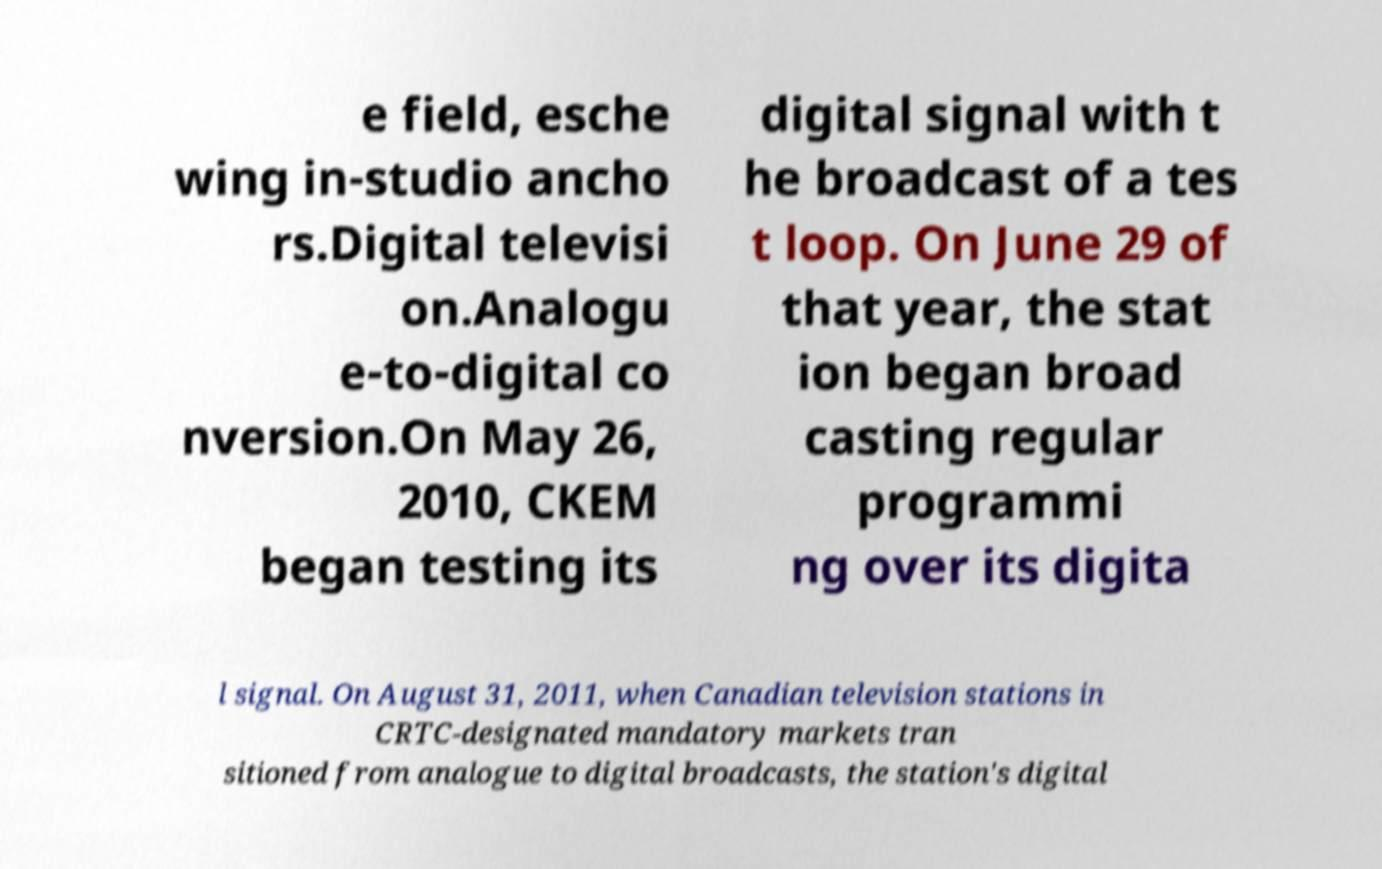Please read and relay the text visible in this image. What does it say? e field, esche wing in-studio ancho rs.Digital televisi on.Analogu e-to-digital co nversion.On May 26, 2010, CKEM began testing its digital signal with t he broadcast of a tes t loop. On June 29 of that year, the stat ion began broad casting regular programmi ng over its digita l signal. On August 31, 2011, when Canadian television stations in CRTC-designated mandatory markets tran sitioned from analogue to digital broadcasts, the station's digital 